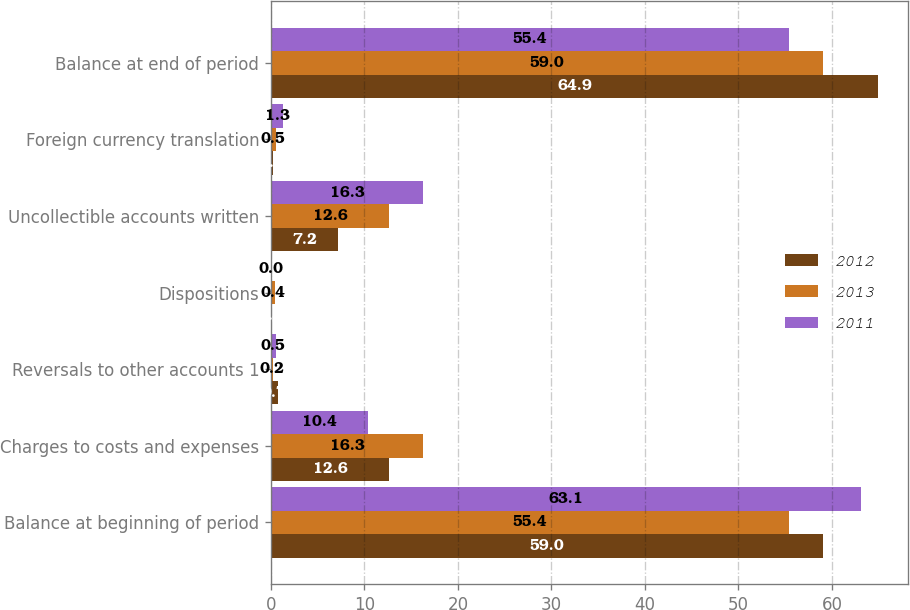Convert chart to OTSL. <chart><loc_0><loc_0><loc_500><loc_500><stacked_bar_chart><ecel><fcel>Balance at beginning of period<fcel>Charges to costs and expenses<fcel>Reversals to other accounts 1<fcel>Dispositions<fcel>Uncollectible accounts written<fcel>Foreign currency translation<fcel>Balance at end of period<nl><fcel>2012<fcel>59<fcel>12.6<fcel>0.7<fcel>0<fcel>7.2<fcel>0.2<fcel>64.9<nl><fcel>2013<fcel>55.4<fcel>16.3<fcel>0.2<fcel>0.4<fcel>12.6<fcel>0.5<fcel>59<nl><fcel>2011<fcel>63.1<fcel>10.4<fcel>0.5<fcel>0<fcel>16.3<fcel>1.3<fcel>55.4<nl></chart> 